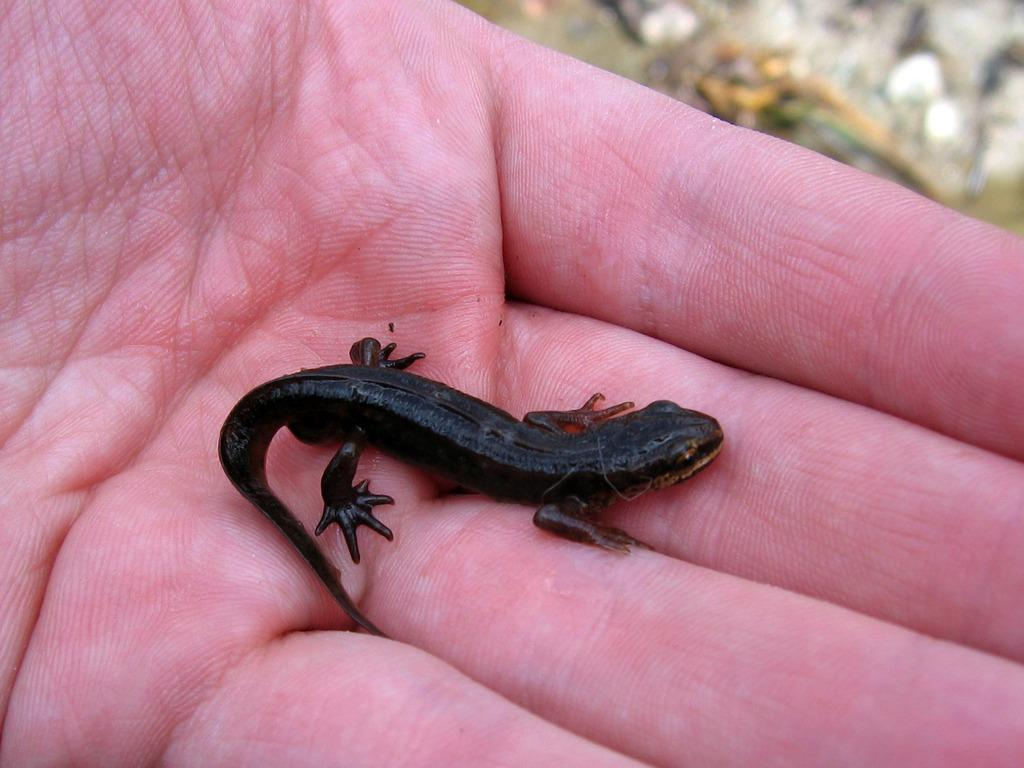What type of animal is in the image? There is a black color lizard in the image. Who is holding the lizard in the image? The lizard is in the hand of a human. Can you describe any specific area in the image? There is a blurred area in the right top of the image. What type of floor can be seen in the image? There is no information about the floor in the image, as the focus is on the lizard and the human holding it. 